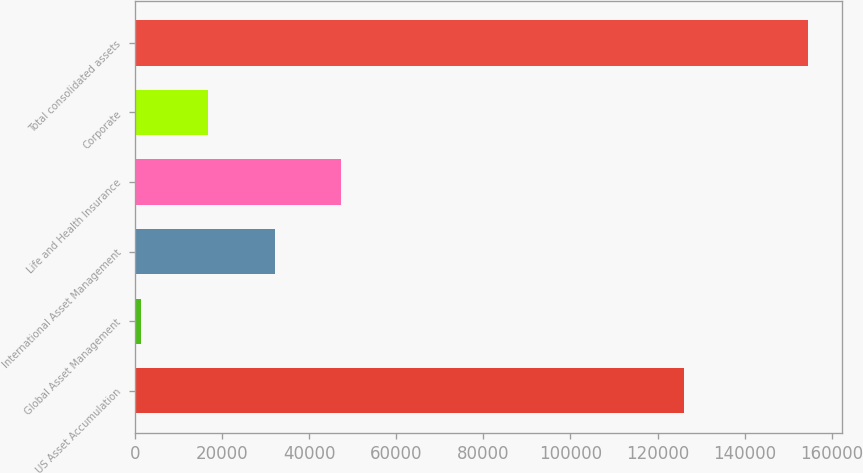Convert chart. <chart><loc_0><loc_0><loc_500><loc_500><bar_chart><fcel>US Asset Accumulation<fcel>Global Asset Management<fcel>International Asset Management<fcel>Life and Health Insurance<fcel>Corporate<fcel>Total consolidated assets<nl><fcel>126131<fcel>1438.9<fcel>32055.2<fcel>47363.3<fcel>16747<fcel>154520<nl></chart> 